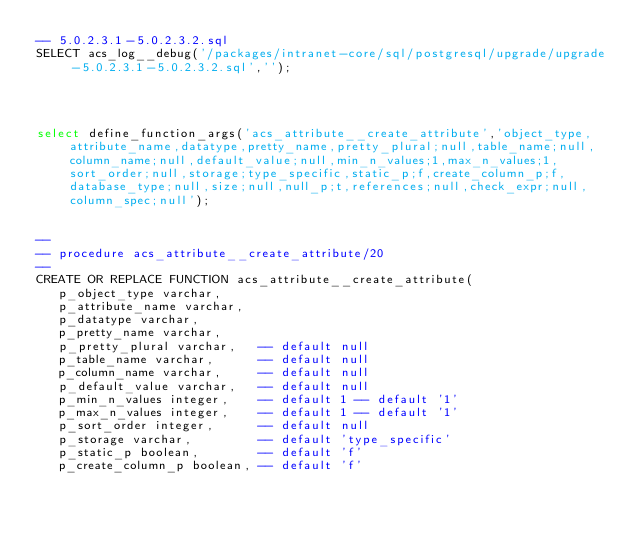Convert code to text. <code><loc_0><loc_0><loc_500><loc_500><_SQL_>-- 5.0.2.3.1-5.0.2.3.2.sql
SELECT acs_log__debug('/packages/intranet-core/sql/postgresql/upgrade/upgrade-5.0.2.3.1-5.0.2.3.2.sql','');




select define_function_args('acs_attribute__create_attribute','object_type,attribute_name,datatype,pretty_name,pretty_plural;null,table_name;null,column_name;null,default_value;null,min_n_values;1,max_n_values;1,sort_order;null,storage;type_specific,static_p;f,create_column_p;f,database_type;null,size;null,null_p;t,references;null,check_expr;null,column_spec;null');


--
-- procedure acs_attribute__create_attribute/20
--
CREATE OR REPLACE FUNCTION acs_attribute__create_attribute(
   p_object_type varchar,
   p_attribute_name varchar,
   p_datatype varchar,
   p_pretty_name varchar,
   p_pretty_plural varchar,   -- default null
   p_table_name varchar,      -- default null
   p_column_name varchar,     -- default null
   p_default_value varchar,   -- default null
   p_min_n_values integer,    -- default 1 -- default '1'
   p_max_n_values integer,    -- default 1 -- default '1'
   p_sort_order integer,      -- default null
   p_storage varchar,         -- default 'type_specific'
   p_static_p boolean,        -- default 'f'
   p_create_column_p boolean, -- default 'f'</code> 